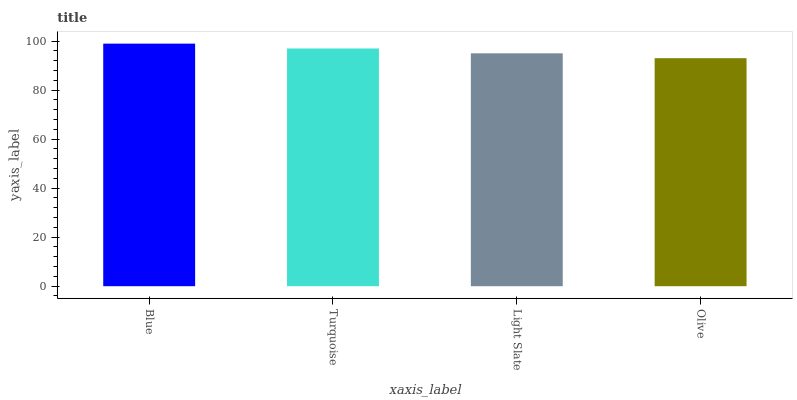Is Olive the minimum?
Answer yes or no. Yes. Is Blue the maximum?
Answer yes or no. Yes. Is Turquoise the minimum?
Answer yes or no. No. Is Turquoise the maximum?
Answer yes or no. No. Is Blue greater than Turquoise?
Answer yes or no. Yes. Is Turquoise less than Blue?
Answer yes or no. Yes. Is Turquoise greater than Blue?
Answer yes or no. No. Is Blue less than Turquoise?
Answer yes or no. No. Is Turquoise the high median?
Answer yes or no. Yes. Is Light Slate the low median?
Answer yes or no. Yes. Is Olive the high median?
Answer yes or no. No. Is Olive the low median?
Answer yes or no. No. 